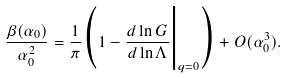<formula> <loc_0><loc_0><loc_500><loc_500>\frac { \beta ( \alpha _ { 0 } ) } { \alpha _ { 0 } ^ { 2 } } = \frac { 1 } { \pi } \Big ( 1 - \frac { d \ln G } { d \ln \Lambda } \Big | _ { q = 0 } \Big ) + O ( \alpha _ { 0 } ^ { 3 } ) .</formula> 